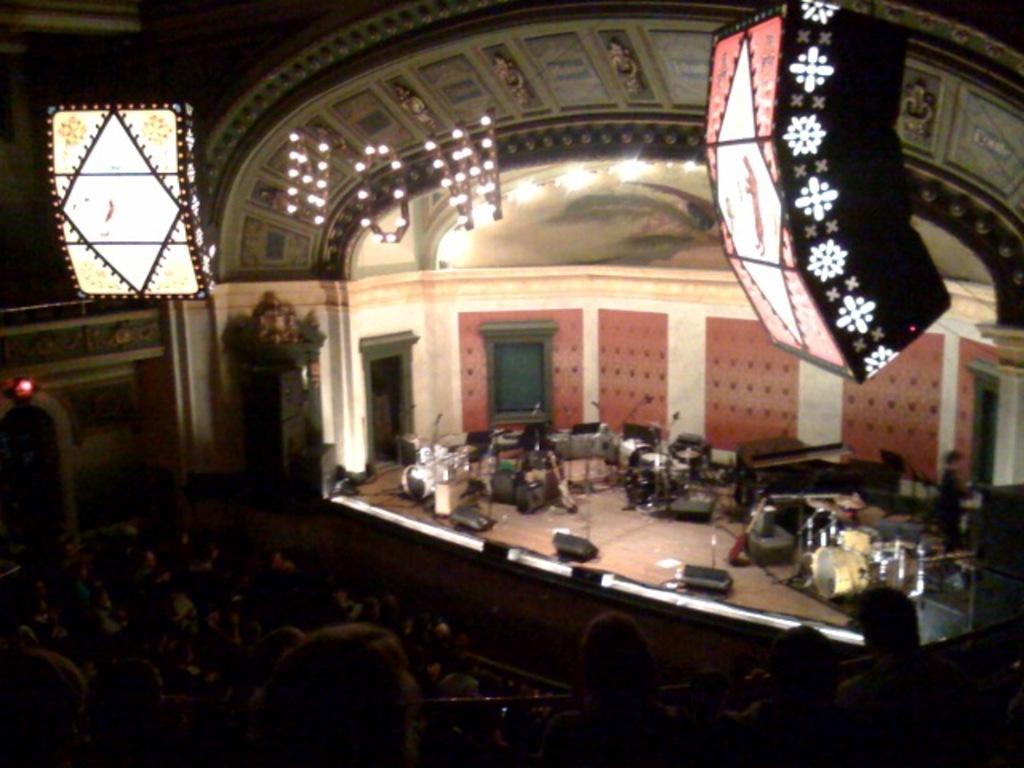Please provide a concise description of this image. In this image there are group of persons in the front. In the background there are objects which are black and white in colour and there are musical instruments and on the top there are lights hanging and there is a wall. 